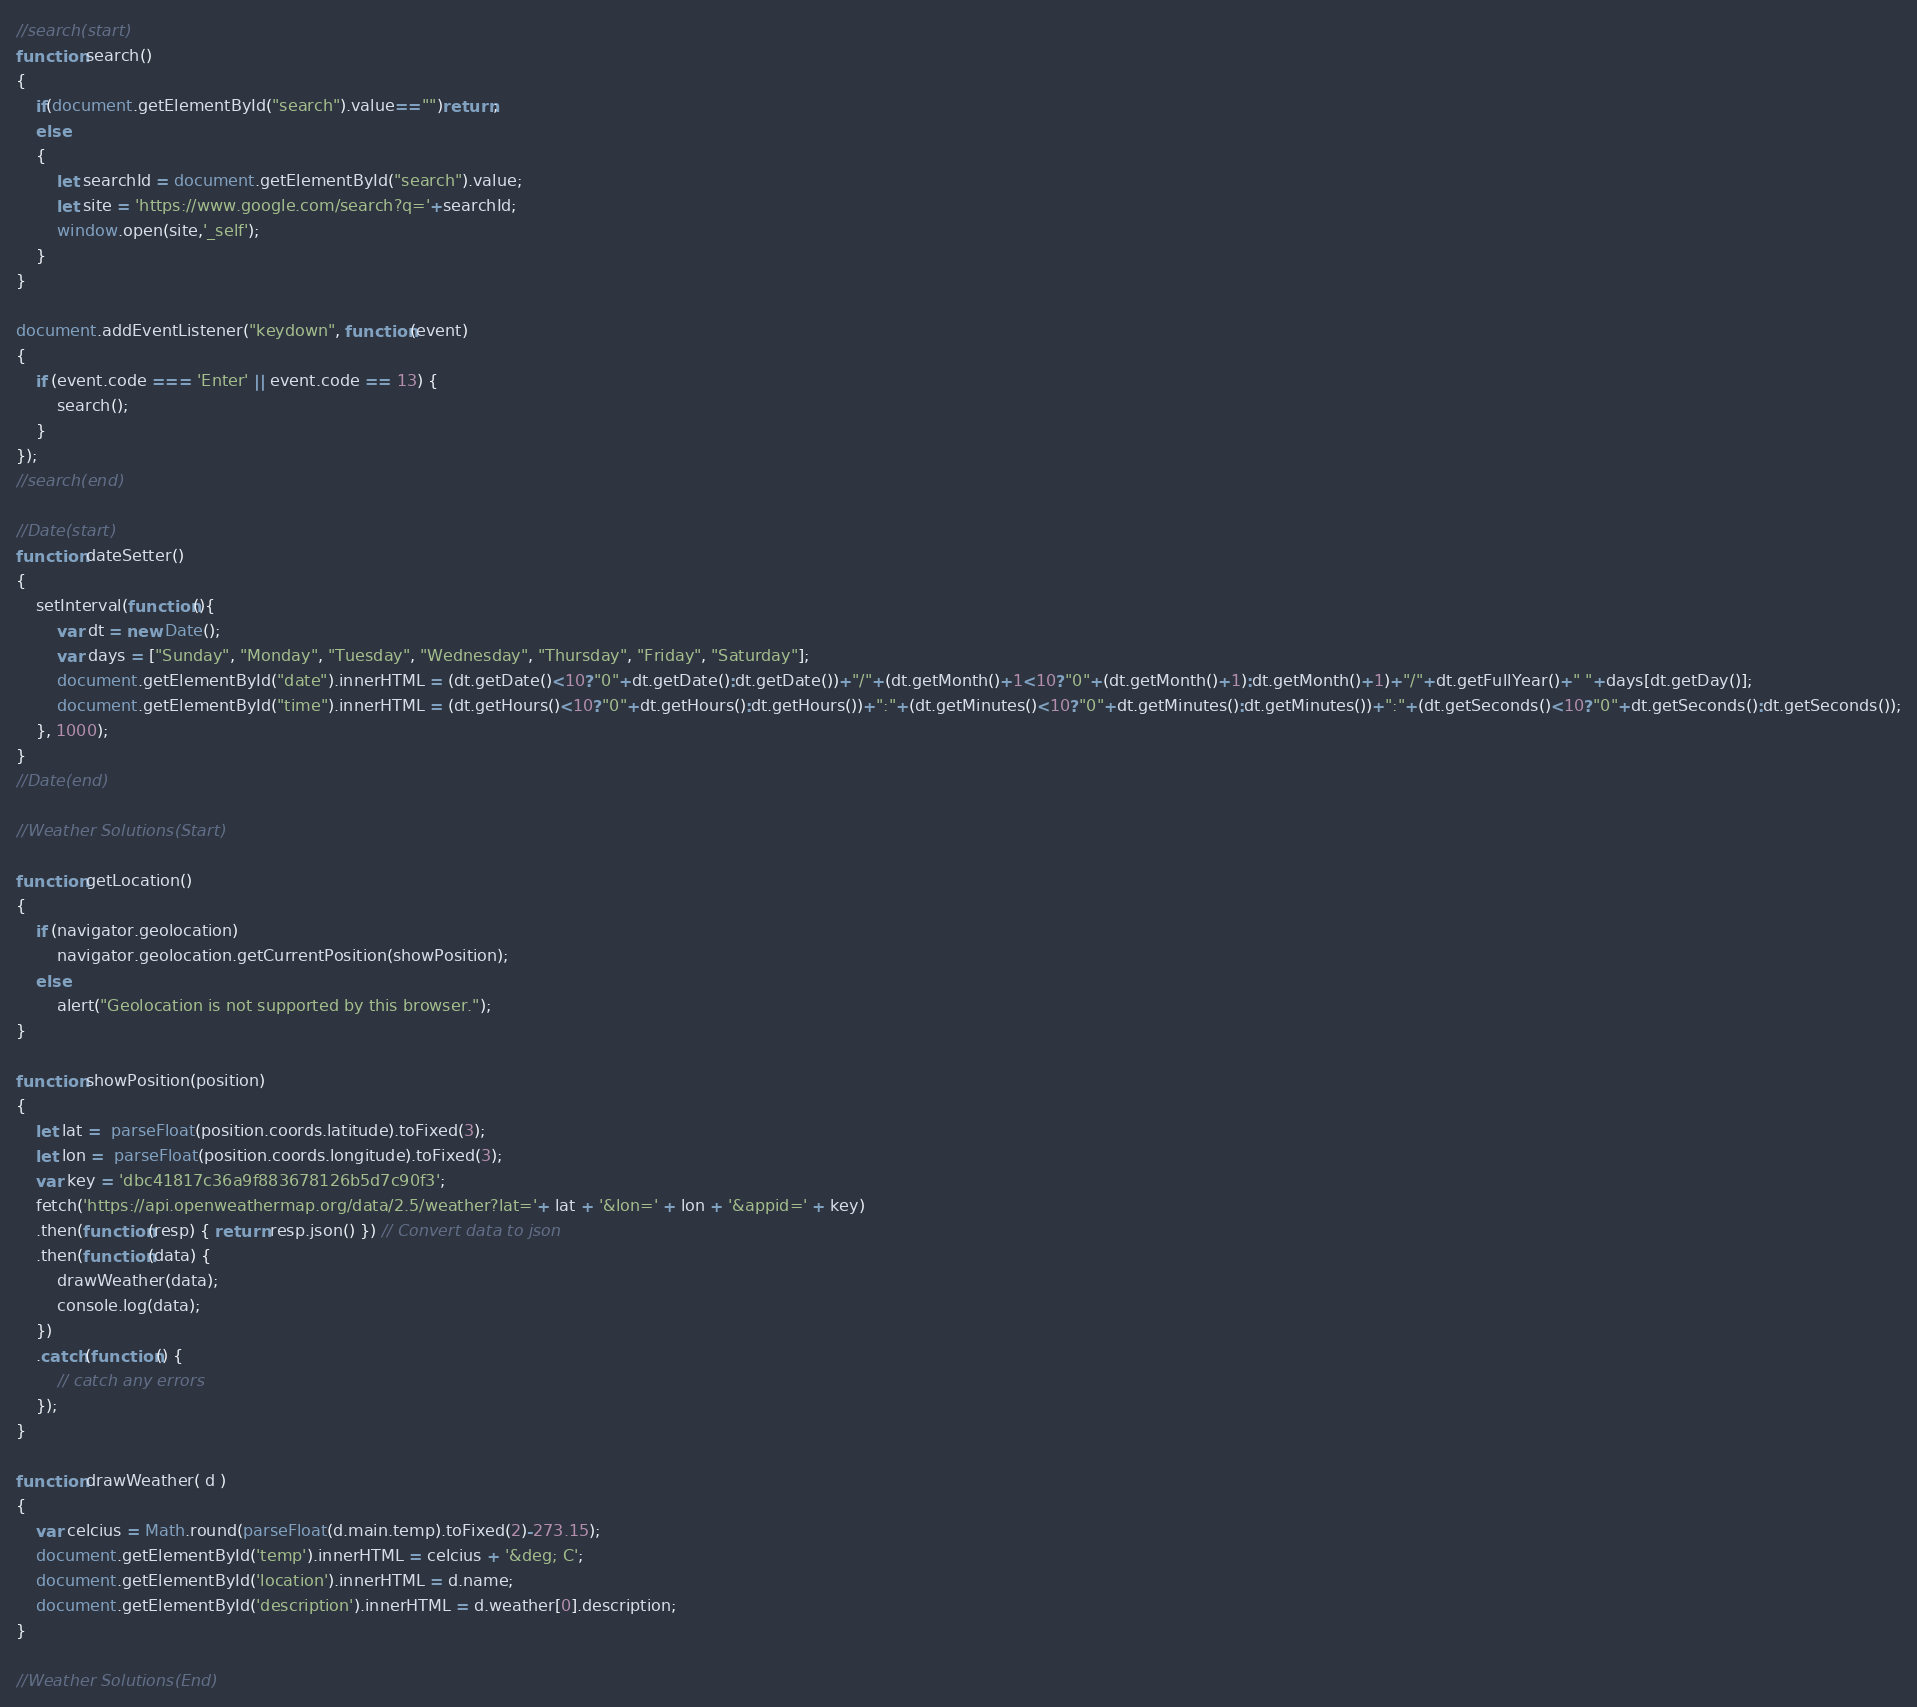Convert code to text. <code><loc_0><loc_0><loc_500><loc_500><_JavaScript_>//search(start)
function search()
{
    if(document.getElementById("search").value=="")return;
    else 
    {
        let searchId = document.getElementById("search").value;
        let site = 'https://www.google.com/search?q='+searchId;
        window.open(site,'_self');
    }
}

document.addEventListener("keydown", function(event) 
{
    if (event.code === 'Enter' || event.code == 13) {
        search();
    }
});
//search(end)

//Date(start)
function dateSetter()
{
    setInterval(function(){ 
        var dt = new Date();
        var days = ["Sunday", "Monday", "Tuesday", "Wednesday", "Thursday", "Friday", "Saturday"];
        document.getElementById("date").innerHTML = (dt.getDate()<10?"0"+dt.getDate():dt.getDate())+"/"+(dt.getMonth()+1<10?"0"+(dt.getMonth()+1):dt.getMonth()+1)+"/"+dt.getFullYear()+" "+days[dt.getDay()];
        document.getElementById("time").innerHTML = (dt.getHours()<10?"0"+dt.getHours():dt.getHours())+":"+(dt.getMinutes()<10?"0"+dt.getMinutes():dt.getMinutes())+":"+(dt.getSeconds()<10?"0"+dt.getSeconds():dt.getSeconds());
    }, 1000);
}
//Date(end)

//Weather Solutions(Start)

function getLocation() 
{
    if (navigator.geolocation)
        navigator.geolocation.getCurrentPosition(showPosition);
    else
        alert("Geolocation is not supported by this browser.");
}
  
function showPosition(position) 
{
    let lat =  parseFloat(position.coords.latitude).toFixed(3); 
    let lon =  parseFloat(position.coords.longitude).toFixed(3);
    var key = 'dbc41817c36a9f883678126b5d7c90f3';
    fetch('https://api.openweathermap.org/data/2.5/weather?lat='+ lat + '&lon=' + lon + '&appid=' + key)  
    .then(function(resp) { return resp.json() }) // Convert data to json
    .then(function(data) {
        drawWeather(data);
        console.log(data);
    })
    .catch(function() {
        // catch any errors
    });
}

function drawWeather( d ) 
{
	var celcius = Math.round(parseFloat(d.main.temp).toFixed(2)-273.15);
	document.getElementById('temp').innerHTML = celcius + '&deg; C';
	document.getElementById('location').innerHTML = d.name;
    document.getElementById('description').innerHTML = d.weather[0].description;
}

//Weather Solutions(End)</code> 